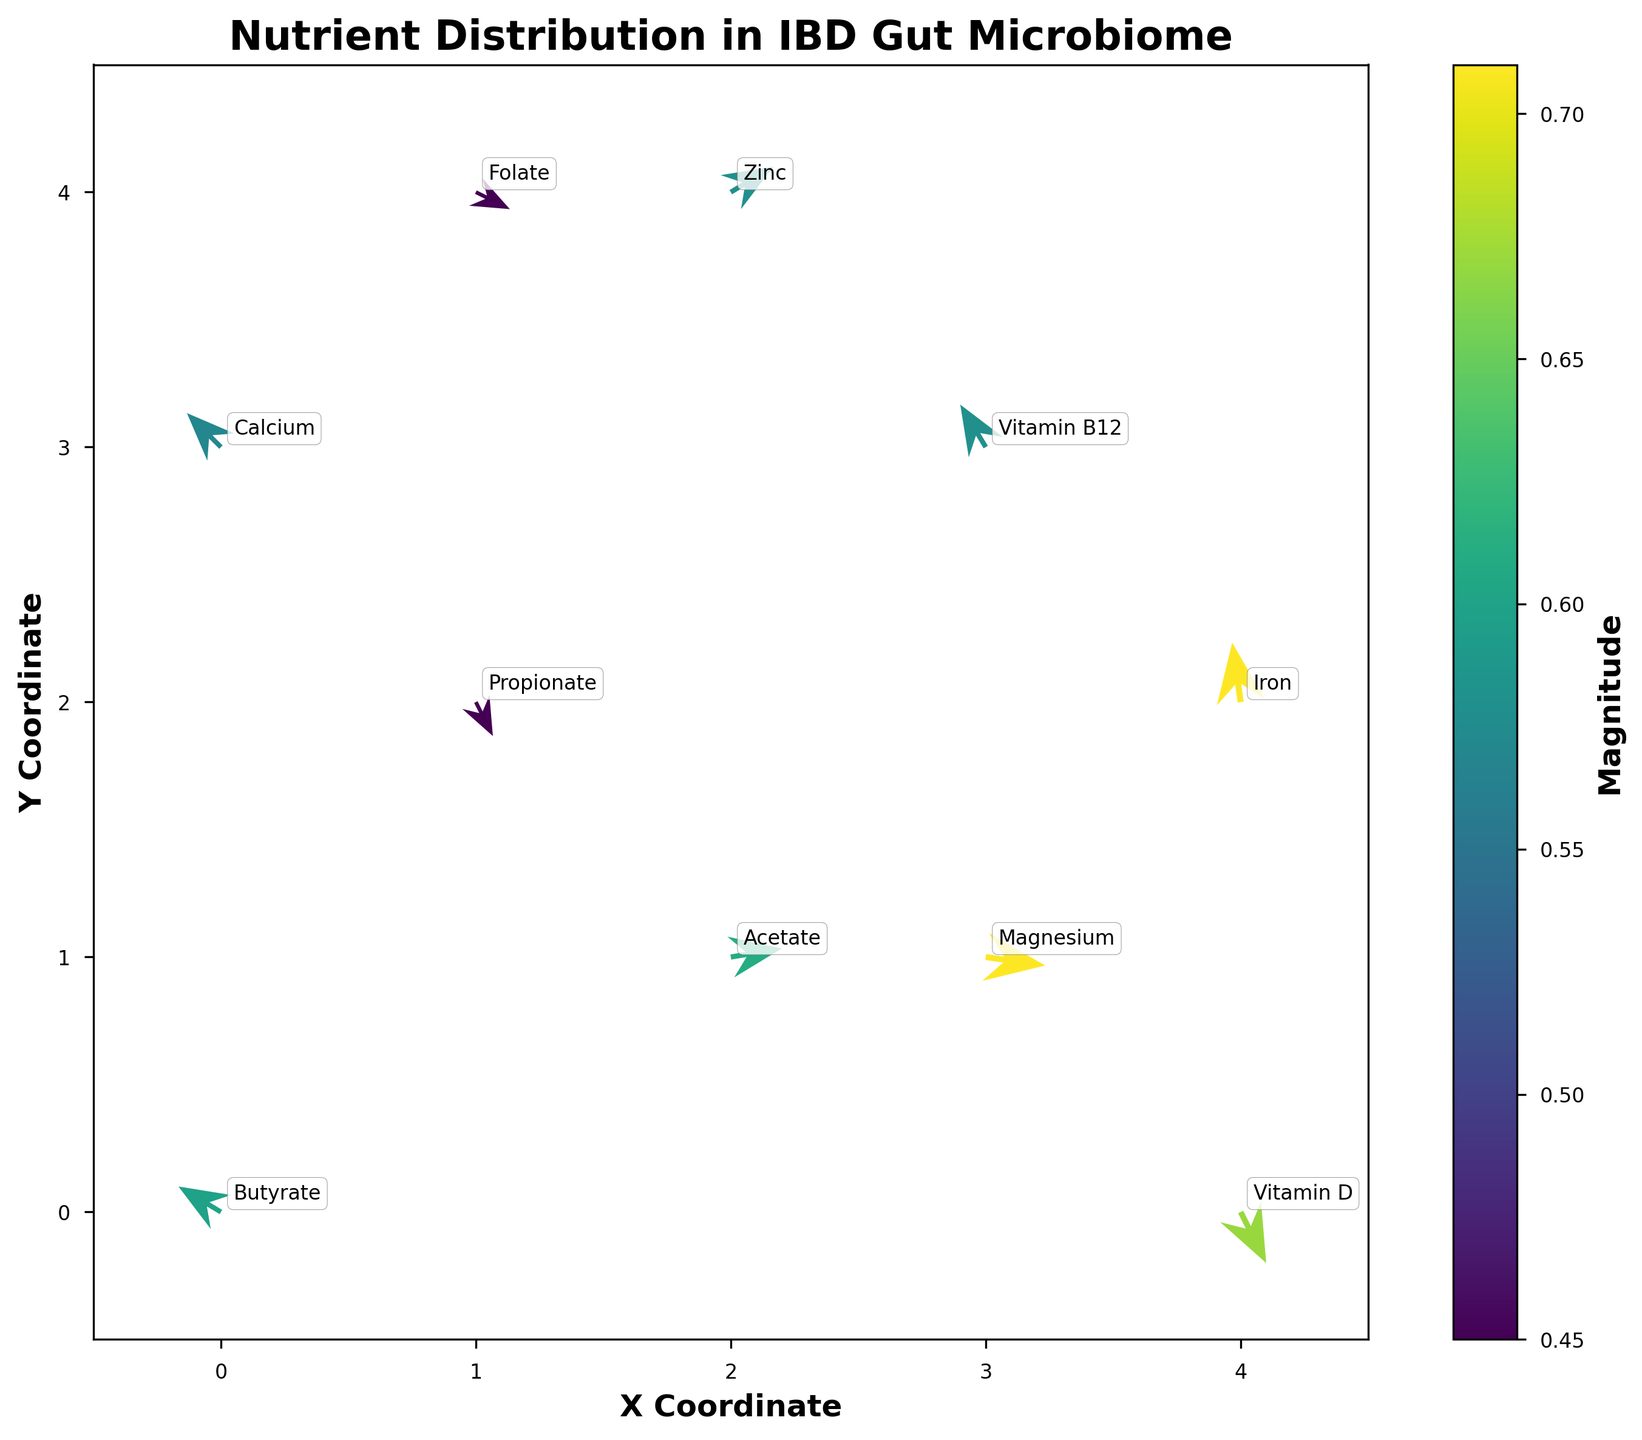What is the title of the plot? The title of the plot is usually found at the top of the figure. In this case, it reads "Nutrient Distribution in IBD Gut Microbiome".
Answer: Nutrient Distribution in IBD Gut Microbiome What nutrient is located at coordinates (1, 2)? To find the nutrient at specific coordinates, look at the annotations near the arrows. At coordinates (1, 2), the nutrient is Propionate.
Answer: Propionate Which nutrient has the highest magnitude value? Examining the magnitudes associated with each nutrient, "Magnesium" and "Iron" both have the highest magnitude value of 0.71.
Answer: Magnesium, Iron What is the direction of the arrow representing "Vitamin D"? The arrows indicate direction using vectors (u, v). "Vitamin D" is located at (4, 0) and it points in the direction given by the vector (0.3, -0.6). This points to the left and downwards.
Answer: Left and Downwards How many nutrients have a magnitude greater than 0.6? By checking the magnitude values, we see that three nutrients, "Acetate" (0.61), "Iron" (0.71), "Magnesium" (0.71), and "Vitamin D" (0.67) have magnitudes greater than 0.6.
Answer: Four Which nutrients are located at the same x-coordinate but different y-coordinates? By examining the x-coordinates: "Calcium" (0,3) and "Butyrate" (0,0) at x=0; "Propionate" (1,2) and "Folate" (1,4) at x=1; "Acetate" (2,1) and "Zinc" (2,4) at x=2.
Answer: Calcium and Butyrate; Propionate and Folate; Acetate and Zinc Which nutrient's vector points upwards and to the right? The vector pointing upwards and to the right will have positive u (right) and positive v (up). "Acetate" at (2, 1) with vector (0.6, 0.1) meets this criterion.
Answer: Acetate What is the net x-component of the vectors for "Propionate" and "Folate"? "Propionate" has a vector component u = 0.2 and "Folate" has u = 0.4. To find the net x-component: 0.2 + 0.4 = 0.6.
Answer: 0.6 Which nutrients are affected by more significant changes in y-coordinates than in x-coordinates? For vectors with larger v than u components: "Vitamin B12" (-0.3, 0.5), "Iron" (-0.1, 0.7).
Answer: Vitamin B12, Iron 